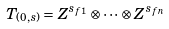<formula> <loc_0><loc_0><loc_500><loc_500>T _ { ( 0 , s ) } = Z ^ { s _ { f 1 } } \otimes \cdots \otimes Z ^ { s _ { f n } }</formula> 